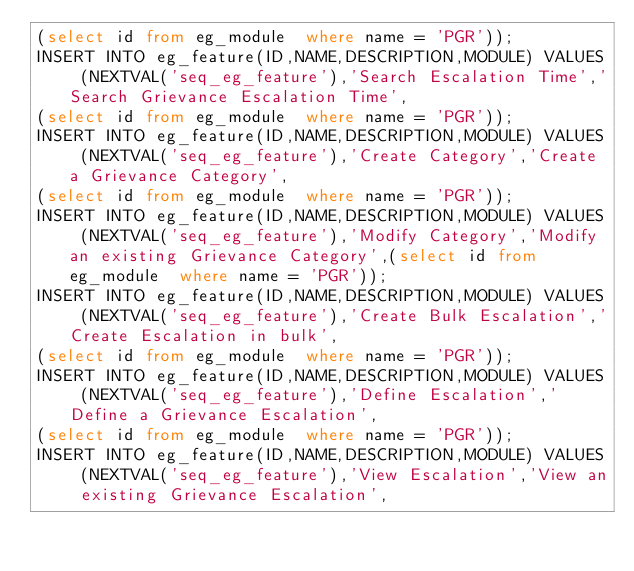<code> <loc_0><loc_0><loc_500><loc_500><_SQL_>(select id from eg_module  where name = 'PGR'));
INSERT INTO eg_feature(ID,NAME,DESCRIPTION,MODULE) VALUES (NEXTVAL('seq_eg_feature'),'Search Escalation Time','Search Grievance Escalation Time',
(select id from eg_module  where name = 'PGR'));
INSERT INTO eg_feature(ID,NAME,DESCRIPTION,MODULE) VALUES (NEXTVAL('seq_eg_feature'),'Create Category','Create a Grievance Category',
(select id from eg_module  where name = 'PGR'));
INSERT INTO eg_feature(ID,NAME,DESCRIPTION,MODULE) VALUES (NEXTVAL('seq_eg_feature'),'Modify Category','Modify an existing Grievance Category',(select id from eg_module  where name = 'PGR'));
INSERT INTO eg_feature(ID,NAME,DESCRIPTION,MODULE) VALUES (NEXTVAL('seq_eg_feature'),'Create Bulk Escalation','Create Escalation in bulk',
(select id from eg_module  where name = 'PGR'));
INSERT INTO eg_feature(ID,NAME,DESCRIPTION,MODULE) VALUES (NEXTVAL('seq_eg_feature'),'Define Escalation','Define a Grievance Escalation',
(select id from eg_module  where name = 'PGR'));
INSERT INTO eg_feature(ID,NAME,DESCRIPTION,MODULE) VALUES (NEXTVAL('seq_eg_feature'),'View Escalation','View an existing Grievance Escalation',</code> 